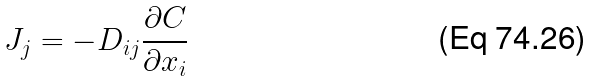<formula> <loc_0><loc_0><loc_500><loc_500>J _ { j } = - D _ { i j } \frac { \partial C } { \partial x _ { i } }</formula> 